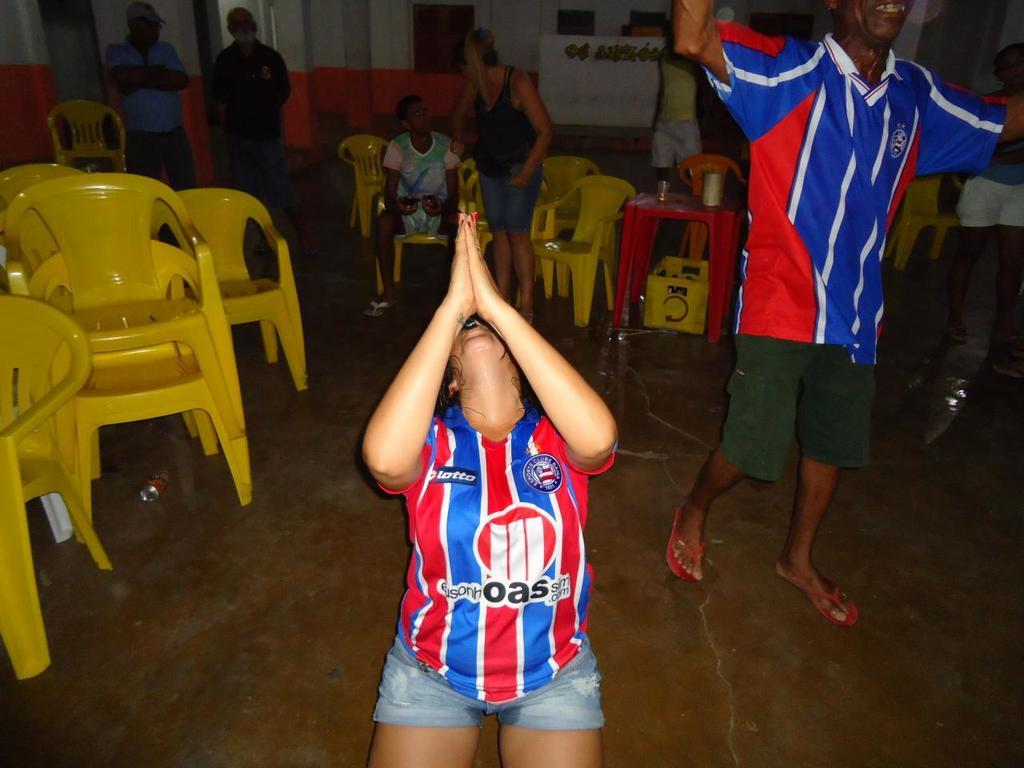<image>
Summarize the visual content of the image. a person with the letters oa on their soccer jersey 